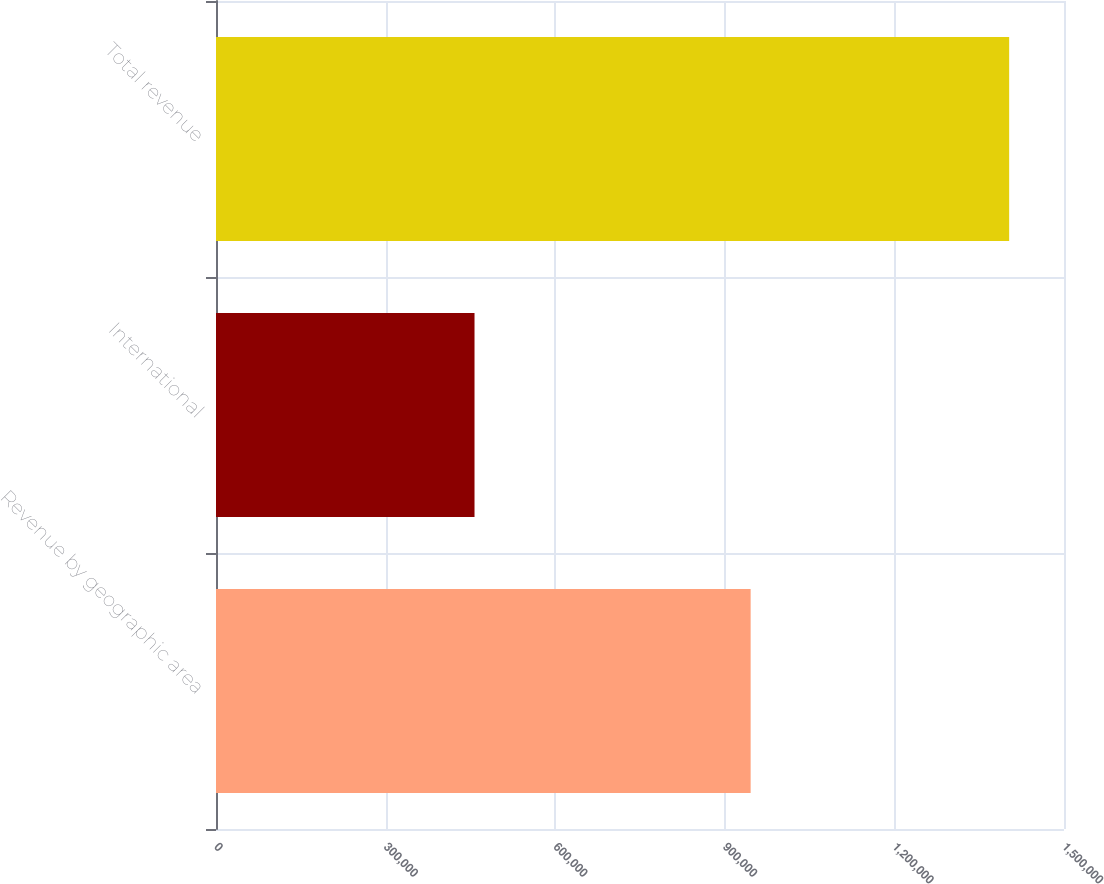Convert chart to OTSL. <chart><loc_0><loc_0><loc_500><loc_500><bar_chart><fcel>Revenue by geographic area<fcel>International<fcel>Total revenue<nl><fcel>945720<fcel>457282<fcel>1.403e+06<nl></chart> 